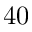<formula> <loc_0><loc_0><loc_500><loc_500>4 0</formula> 